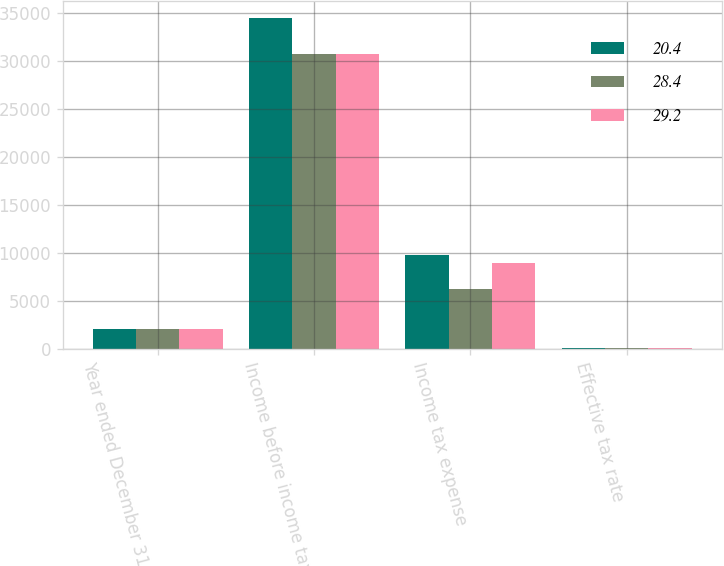Convert chart. <chart><loc_0><loc_0><loc_500><loc_500><stacked_bar_chart><ecel><fcel>Year ended December 31 (in<fcel>Income before income tax<fcel>Income tax expense<fcel>Effective tax rate<nl><fcel>20.4<fcel>2016<fcel>34536<fcel>9803<fcel>28.4<nl><fcel>28.4<fcel>2015<fcel>30702<fcel>6260<fcel>20.4<nl><fcel>29.2<fcel>2014<fcel>30699<fcel>8954<fcel>29.2<nl></chart> 